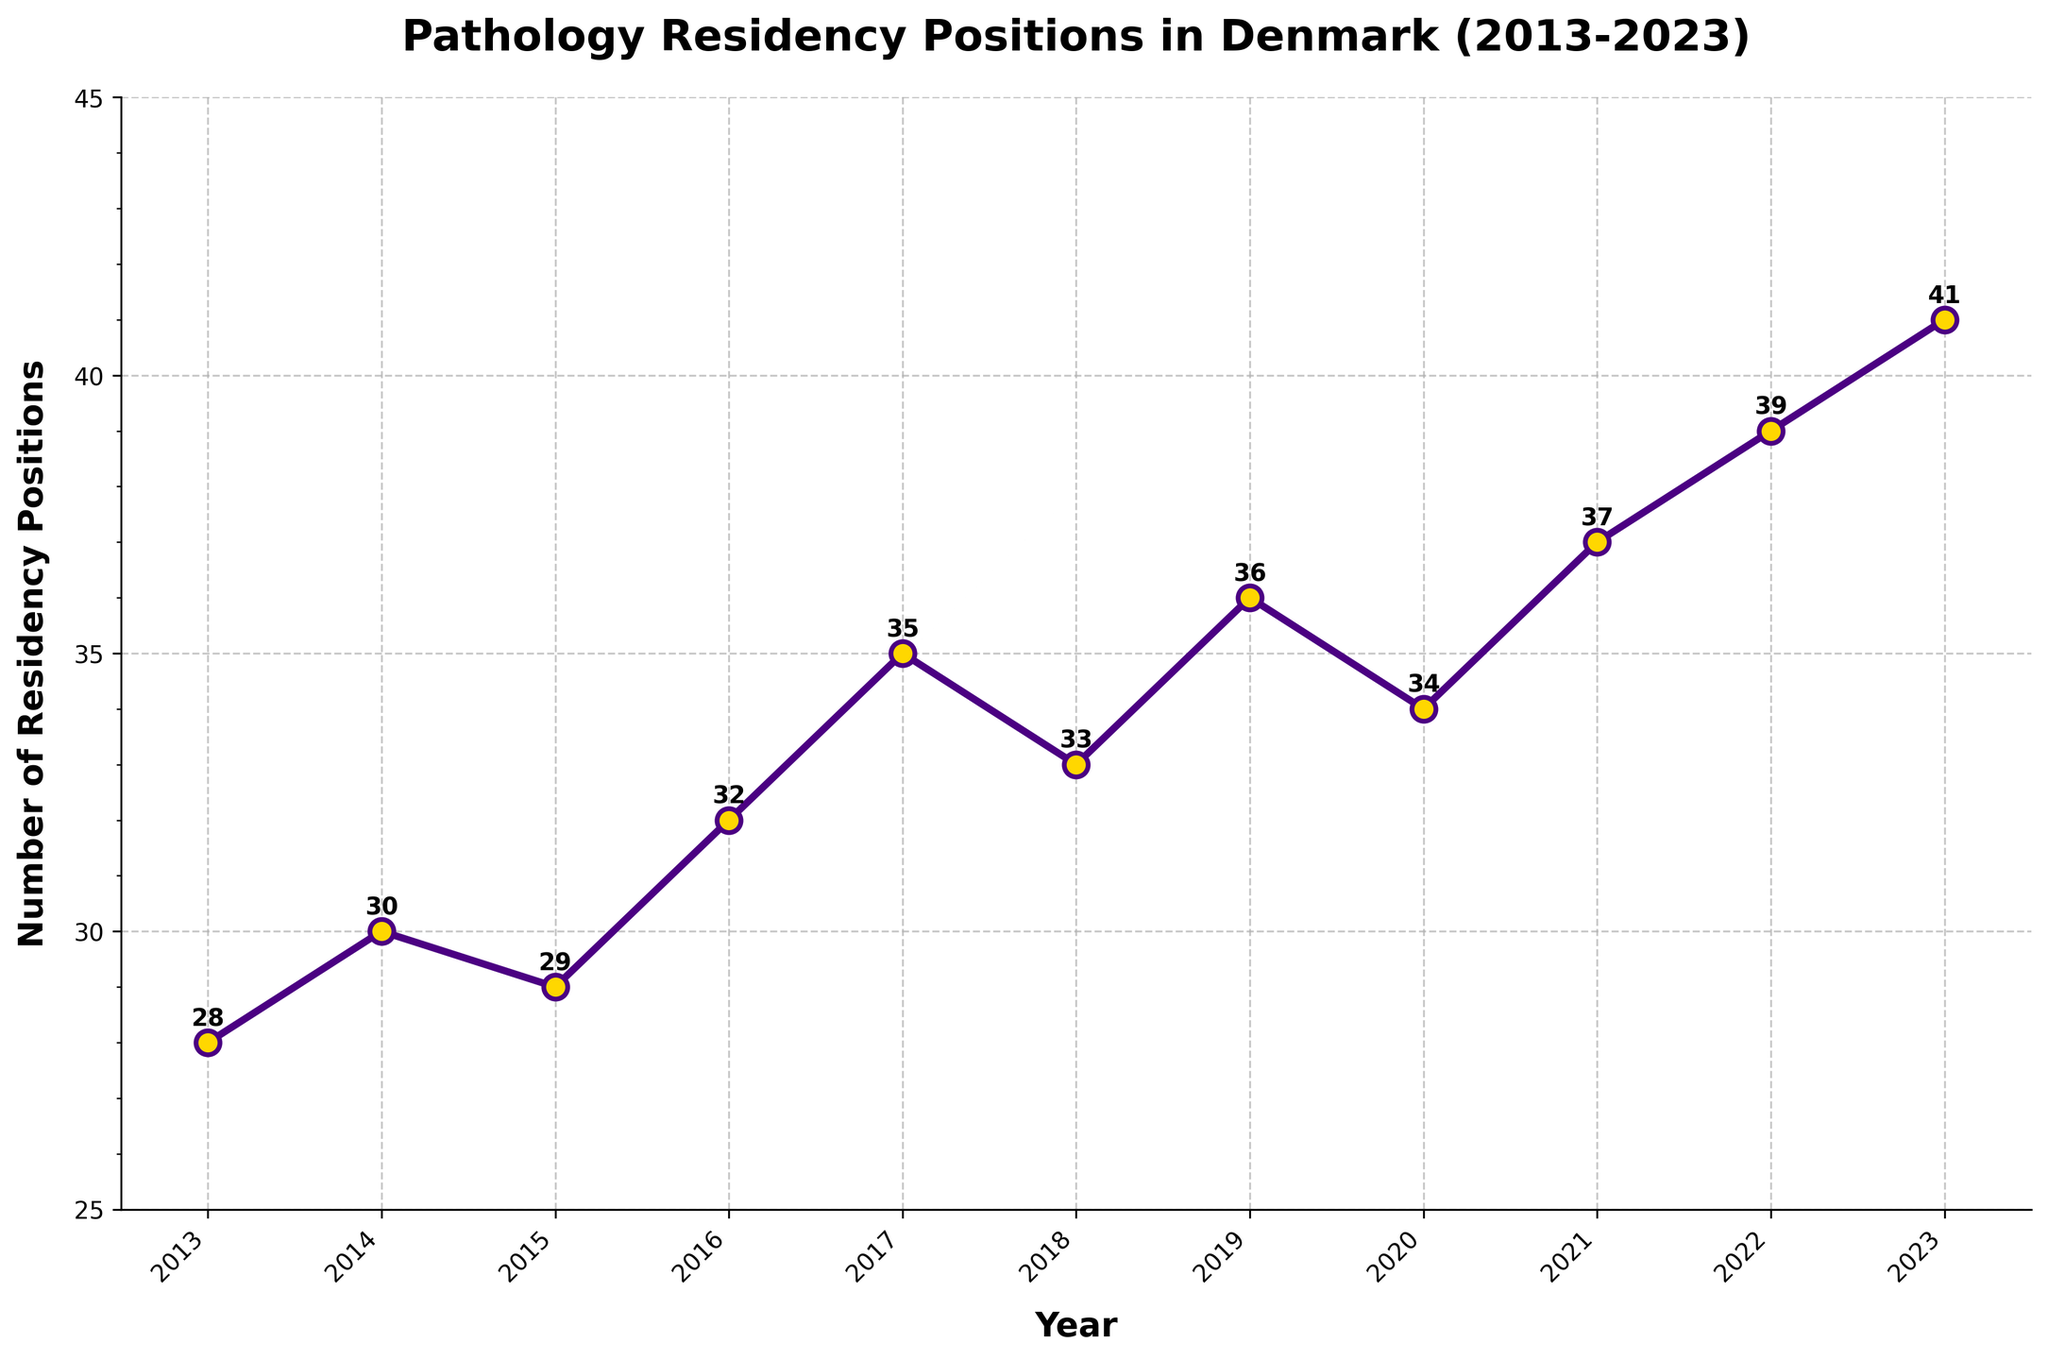What year saw the highest number of pathology residency positions in Denmark? The highest number of pathology residency positions is depicted at the peak of the line chart. From the annotated numbers, the highest value, 41, corresponds to the year 2023.
Answer: 2023 How many more residency positions were available in 2023 compared to 2013? To find the difference in residency positions between 2023 and 2013, subtract the number of positions in 2013 from the number in 2023. From the annotations, 41 (2023) - 28 (2013) = 13.
Answer: 13 How did the number of residency positions in 2021 compare to 2020? According to the line chart, compare the positions for 2021 and 2020: 2021 had 37 positions, and 2020 had 34. 37-34 = 3. Thus, 2021 had 3 more positions than 2020.
Answer: 3 more What's the range of pathology residency positions available over the last decade? The range is calculated by subtracting the minimum value from the maximum value. The minimum number of positions is 28 (2013) and the maximum is 41 (2023). Thus, range = 41 - 28 = 13.
Answer: 13 By how many positions did the number change between 2018 and 2019? From 2018 to 2019, the number of positions increased from 33 to 36. The change is calculated by 36 - 33 = 3.
Answer: 3 